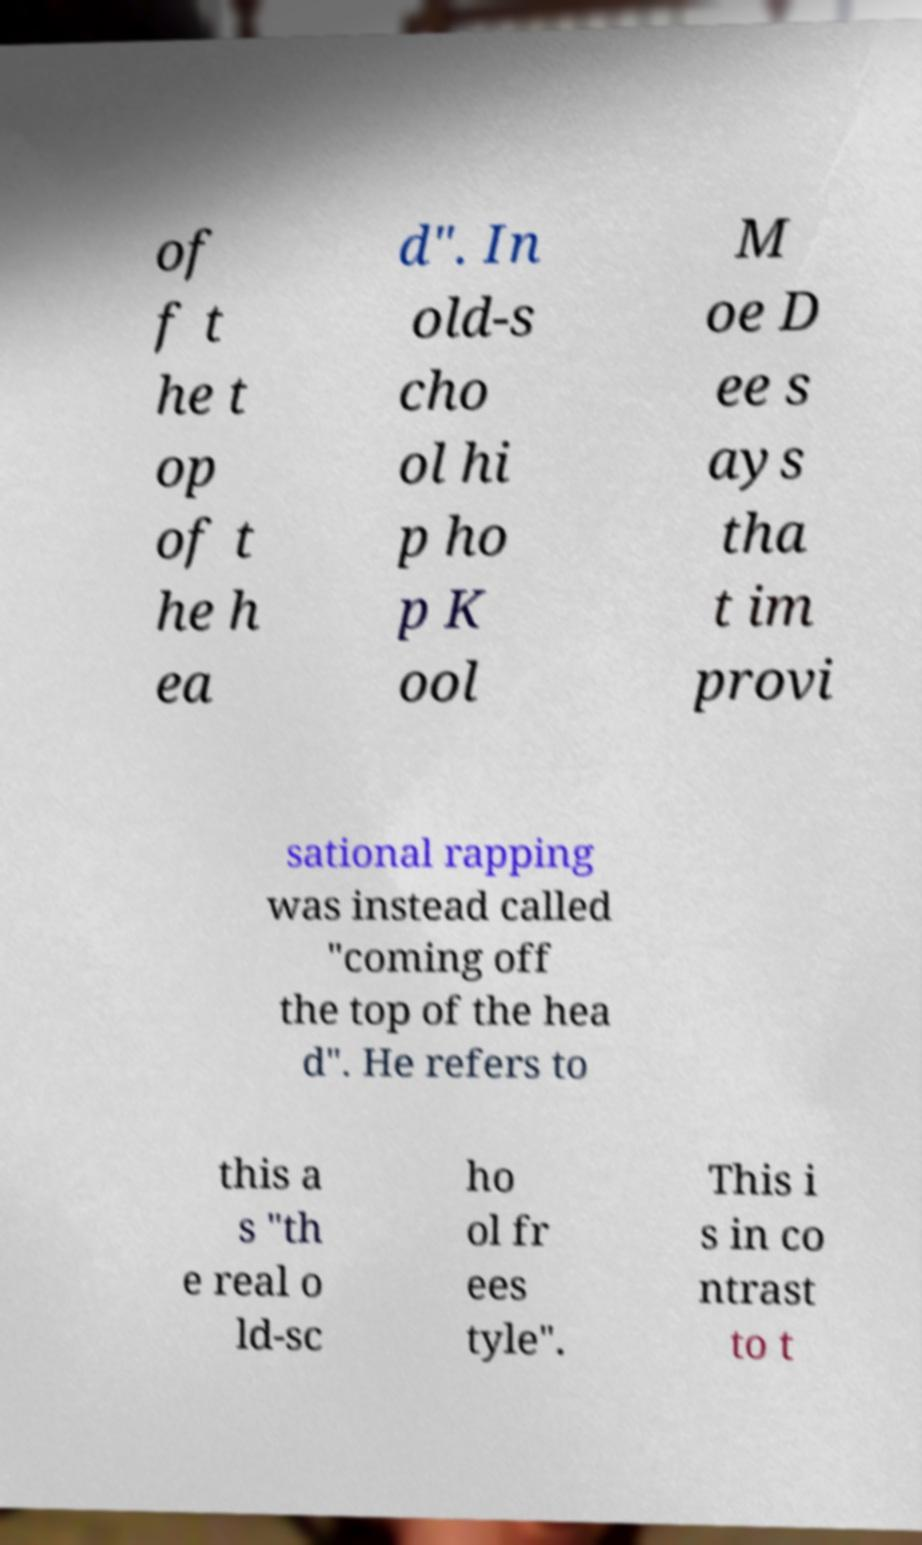For documentation purposes, I need the text within this image transcribed. Could you provide that? of f t he t op of t he h ea d". In old-s cho ol hi p ho p K ool M oe D ee s ays tha t im provi sational rapping was instead called "coming off the top of the hea d". He refers to this a s "th e real o ld-sc ho ol fr ees tyle". This i s in co ntrast to t 